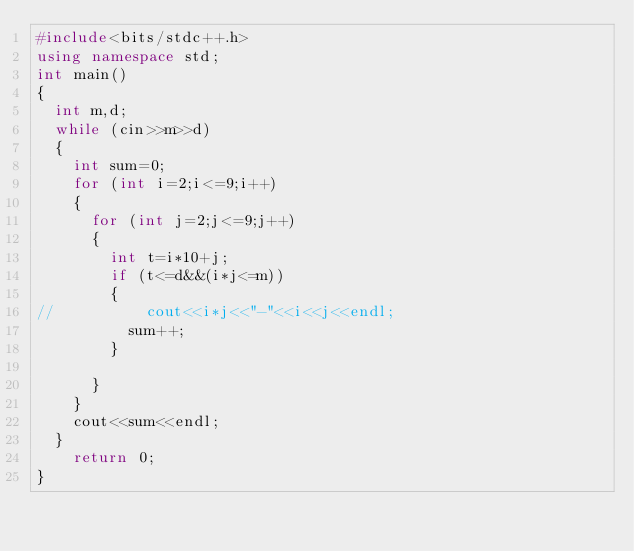<code> <loc_0><loc_0><loc_500><loc_500><_C++_>#include<bits/stdc++.h>
using namespace std;
int main()
{
	int m,d;
	while (cin>>m>>d)
	{
		int sum=0;
		for (int i=2;i<=9;i++)
		{
			for (int j=2;j<=9;j++)
			{
				int t=i*10+j;
				if (t<=d&&(i*j<=m))
				{
//					cout<<i*j<<"-"<<i<<j<<endl;
					sum++;
				}
						
			}		
		}	
		cout<<sum<<endl;
	}
    return 0;
}
</code> 